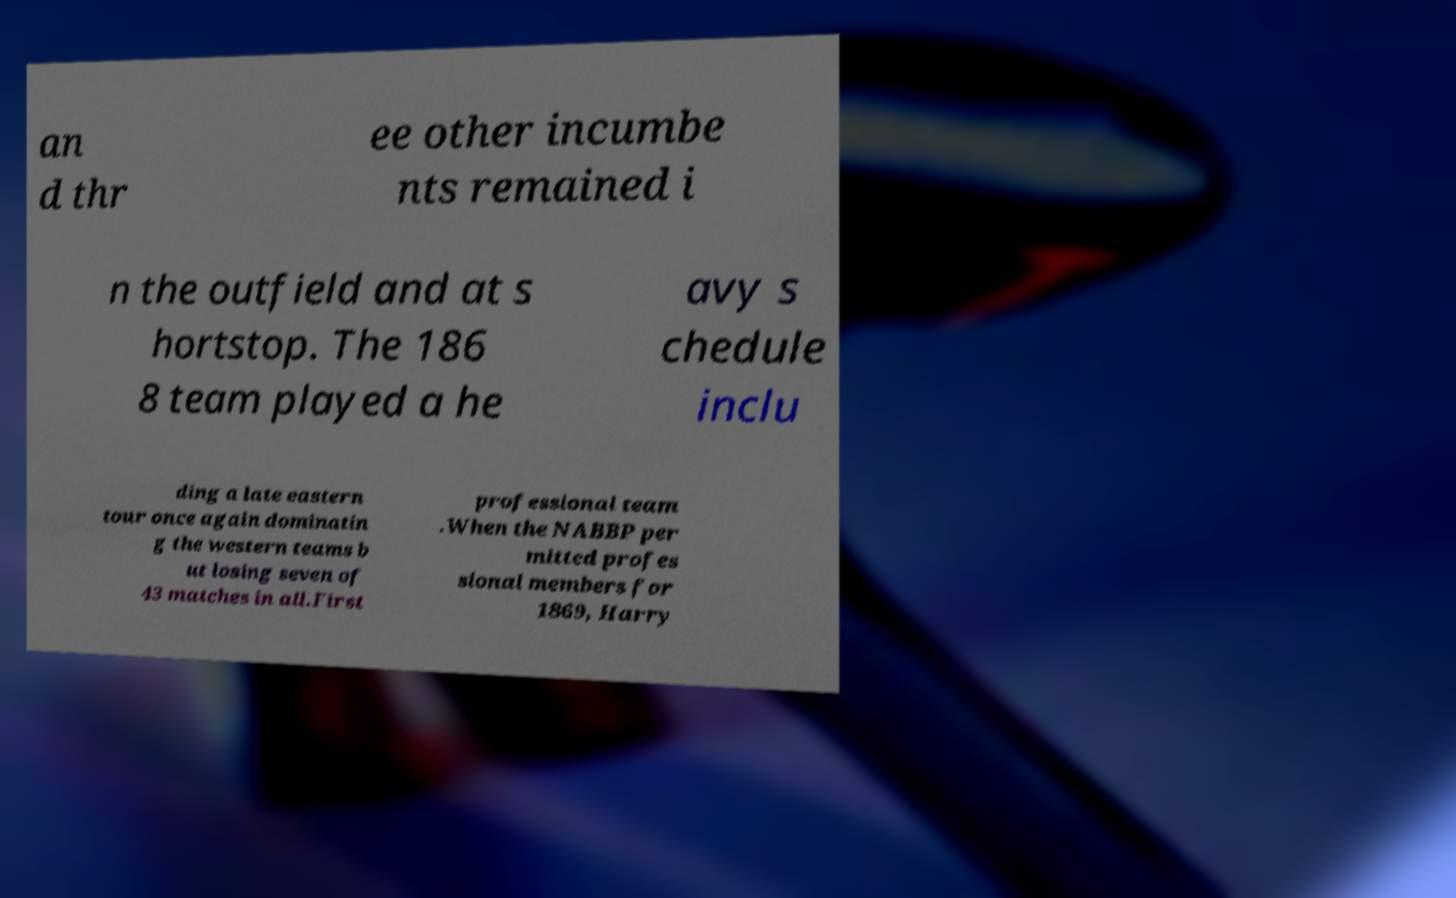What messages or text are displayed in this image? I need them in a readable, typed format. an d thr ee other incumbe nts remained i n the outfield and at s hortstop. The 186 8 team played a he avy s chedule inclu ding a late eastern tour once again dominatin g the western teams b ut losing seven of 43 matches in all.First professional team .When the NABBP per mitted profes sional members for 1869, Harry 